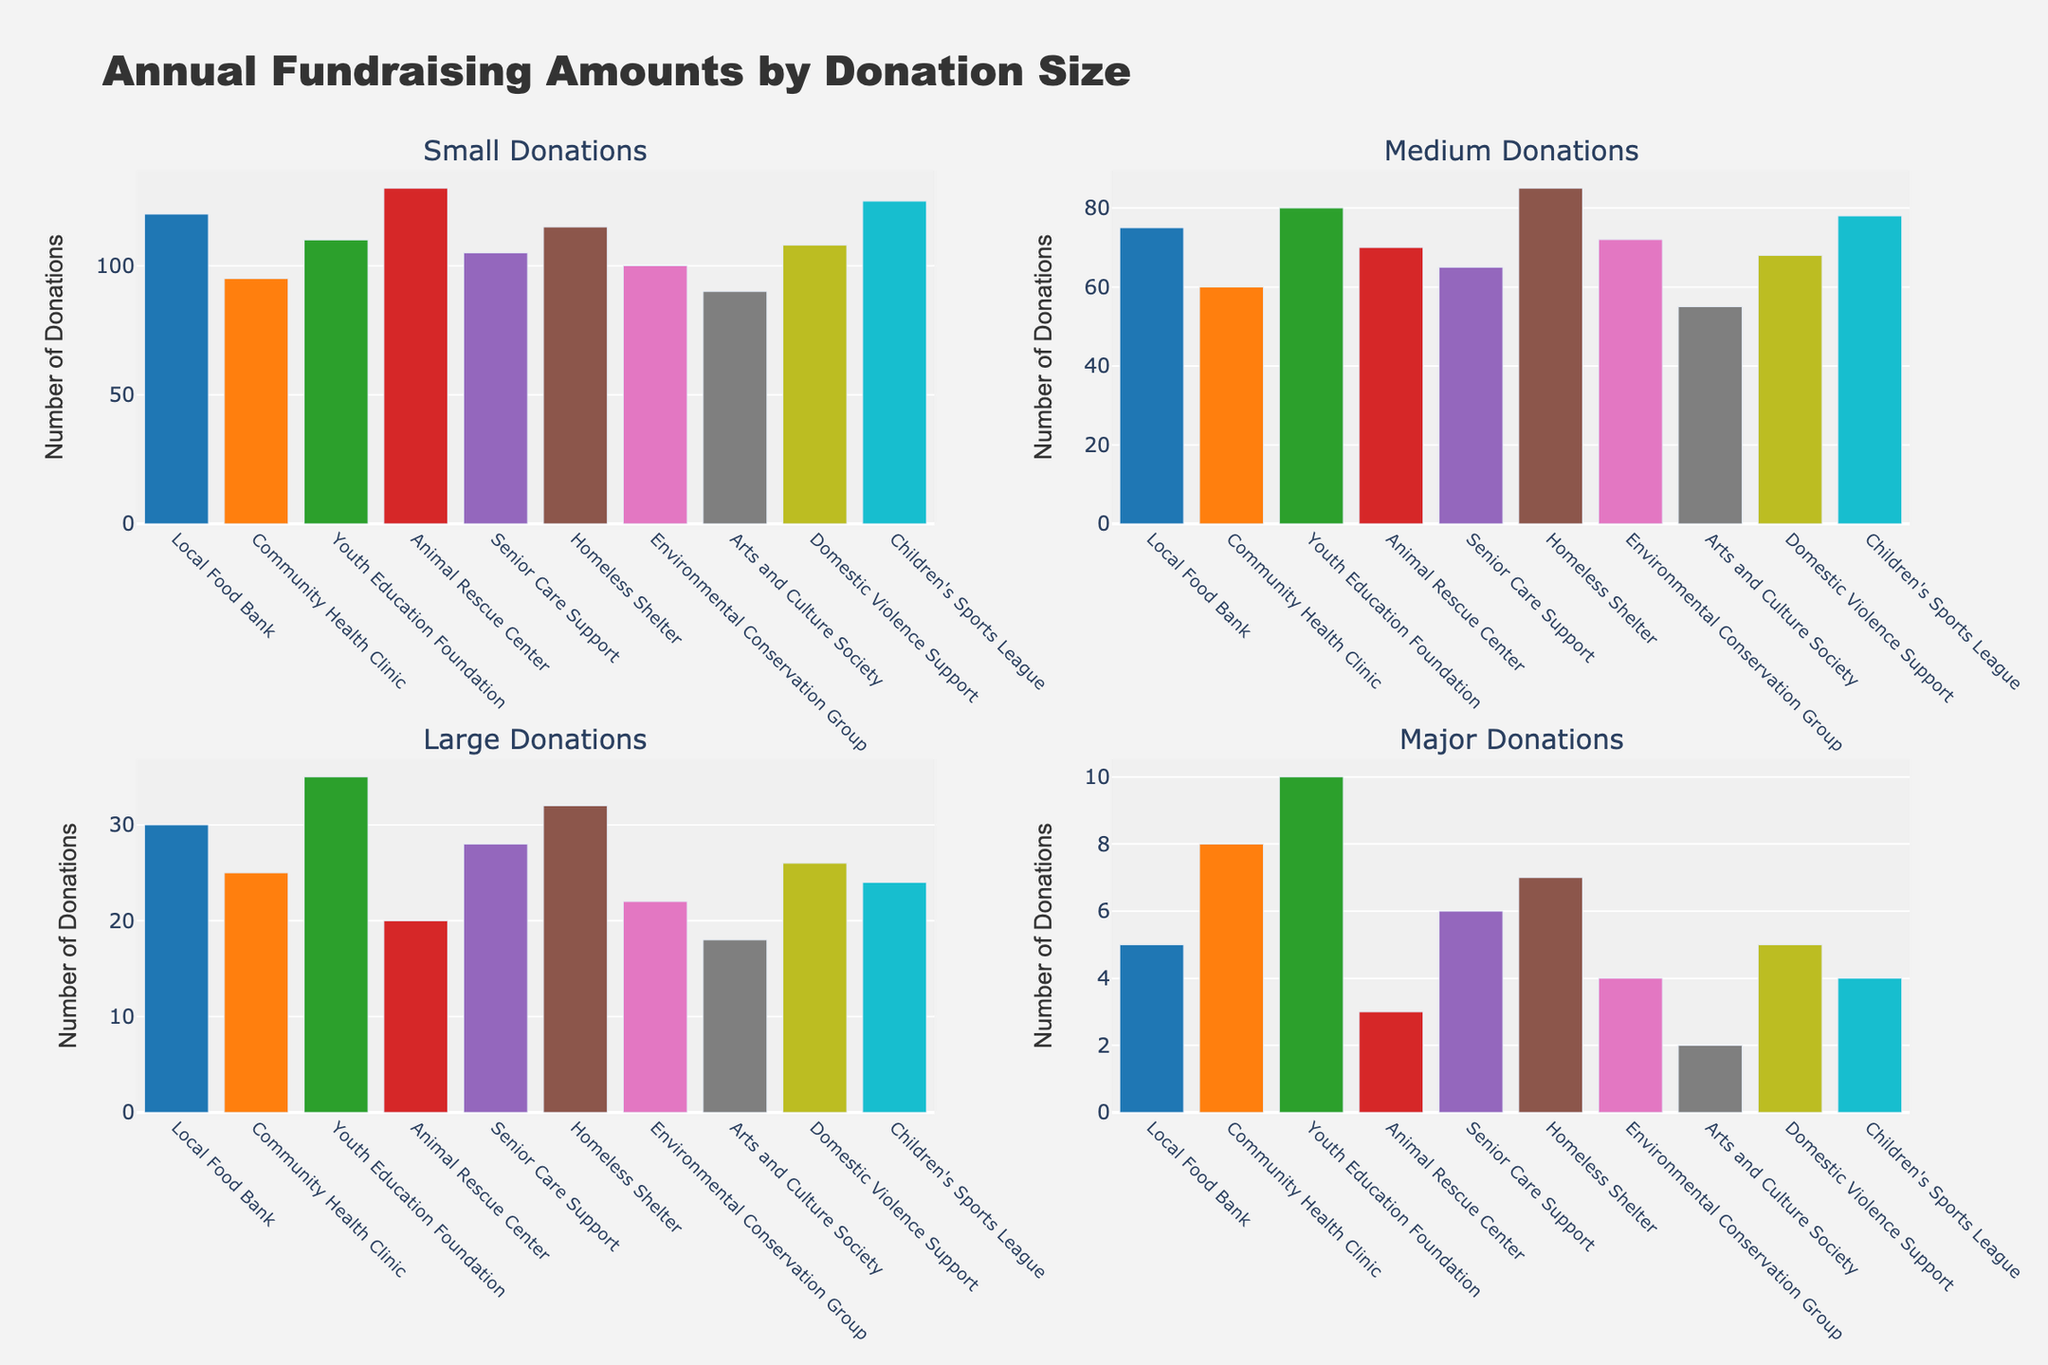What is the title of the figure? The title of the figure is usually located at the top of the chart and provides a brief description of what the chart represents.
Answer: Annual Fundraising Amounts by Donation Size How many subplots are present in the figure? By observing the layout of the figure, you can see how many separate plots are displayed. In this case, there are four distinct subplots, each representing different donation size categories.
Answer: 4 Which charity received the highest number of Small Donations? To determine this, check the bar heights in the subplot for Small Donations. The charity with the tallest bar in this subplot is the one that has received the highest number of Small Donations.
Answer: Animal Rescue Center What is the total number of Medium Donations received by the Community Health Clinic and the Homeless Shelter combined? To find this, locate the Medium Donations subplot, identify the bars for Community Health Clinic and Homeless Shelter, and then sum their values: Community Health Clinic (60) + Homeless Shelter (85).
Answer: 145 Which category has the lowest number of donations for the Arts and Culture Society? Look at the bars corresponding to the Arts and Culture Society in all subplots and identify the shortest one, indicating the lowest number of donations.
Answer: Major Donations Compare the Major Donations received by the Local Food Bank and the Youth Education Foundation. Which received more, and by how much? Locate the Major Donations subplot and compare the heights of the bars for Local Food Bank (5) and Youth Education Foundation (10). Subtract the smaller value from the larger to find the difference.
Answer: Youth Education Foundation by 5 What is the average number of Large Donations received by all charities? Add up the number of Large Donations for all charities and divide by the number of charities. Sum: 30 + 25 + 35 + 20 + 28 + 32 + 22 + 18 + 26 + 24 = 260. Divide by 10 (number of charities): 260 / 10.
Answer: 26 How does the number of Major Donations for the Community Health Clinic compare to its number of Small Donations? Compare the heights of the bars for Community Health Clinic in the Major Donations subplot (8) and Small Donations subplot (95).
Answer: Small Donations are higher by 87 Which donation size category has the greatest range in donations across all charities? The range is determined by the difference between the highest and lowest values in each category. Compare the maximum and minimum values for each subplot to find the one with the largest range.
Answer: Small Donations How many charities received more than 100 Small Donations? Check the Small Donations subplot for bars exceeding the 100 marks and count the number of such bars: Local Food Bank, Youth Education Foundation, Animal Rescue Center, Homeless Shelter, Children's Sports League.
Answer: 5 